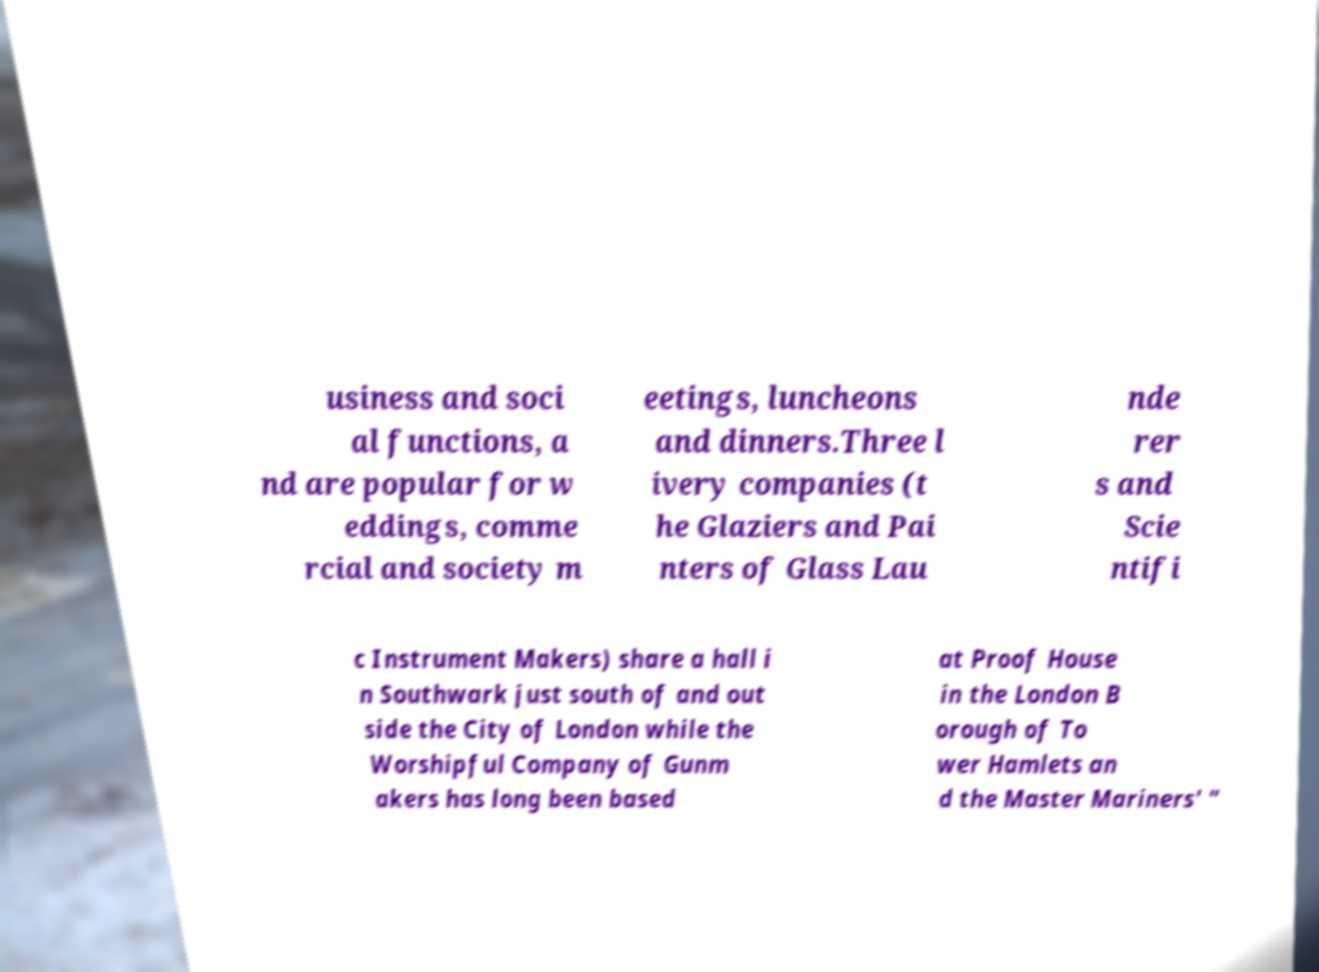What messages or text are displayed in this image? I need them in a readable, typed format. usiness and soci al functions, a nd are popular for w eddings, comme rcial and society m eetings, luncheons and dinners.Three l ivery companies (t he Glaziers and Pai nters of Glass Lau nde rer s and Scie ntifi c Instrument Makers) share a hall i n Southwark just south of and out side the City of London while the Worshipful Company of Gunm akers has long been based at Proof House in the London B orough of To wer Hamlets an d the Master Mariners' " 